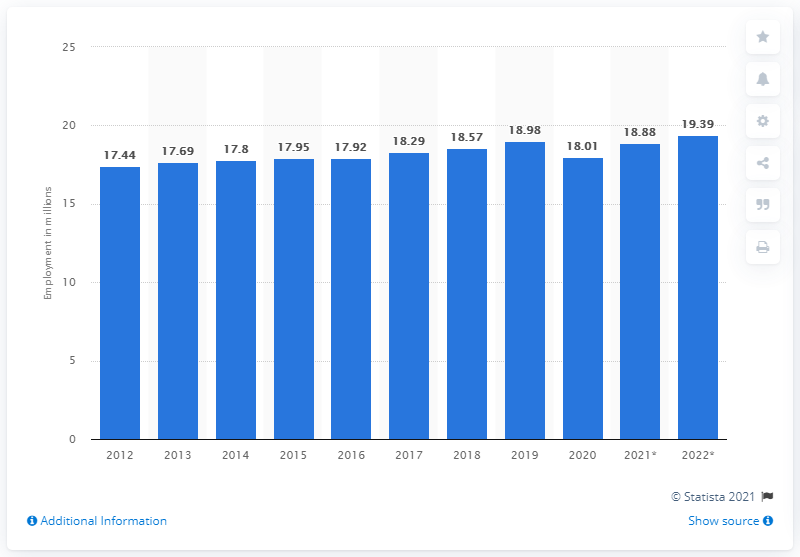Indicate a few pertinent items in this graphic. In 2019, it is estimated that 18.88 people were employed in Canada. 